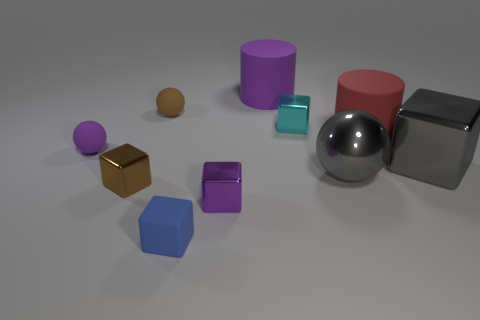What is the material of the blue cube that is the same size as the brown ball?
Your response must be concise. Rubber. Is there a small brown object on the right side of the tiny brown thing that is in front of the gray sphere?
Your answer should be very brief. Yes. What number of other things are the same color as the big shiny cube?
Your response must be concise. 1. The red matte object has what size?
Your response must be concise. Large. Are any gray shiny objects visible?
Offer a terse response. Yes. Is the number of tiny purple metal blocks that are behind the purple shiny block greater than the number of big shiny balls in front of the tiny brown block?
Your answer should be very brief. No. The tiny thing that is behind the small purple matte sphere and to the right of the brown matte sphere is made of what material?
Ensure brevity in your answer.  Metal. Do the purple metallic thing and the brown metal object have the same shape?
Provide a short and direct response. Yes. Is there any other thing that is the same size as the blue rubber block?
Offer a very short reply. Yes. There is a red matte thing; how many matte cylinders are to the left of it?
Keep it short and to the point. 1. 